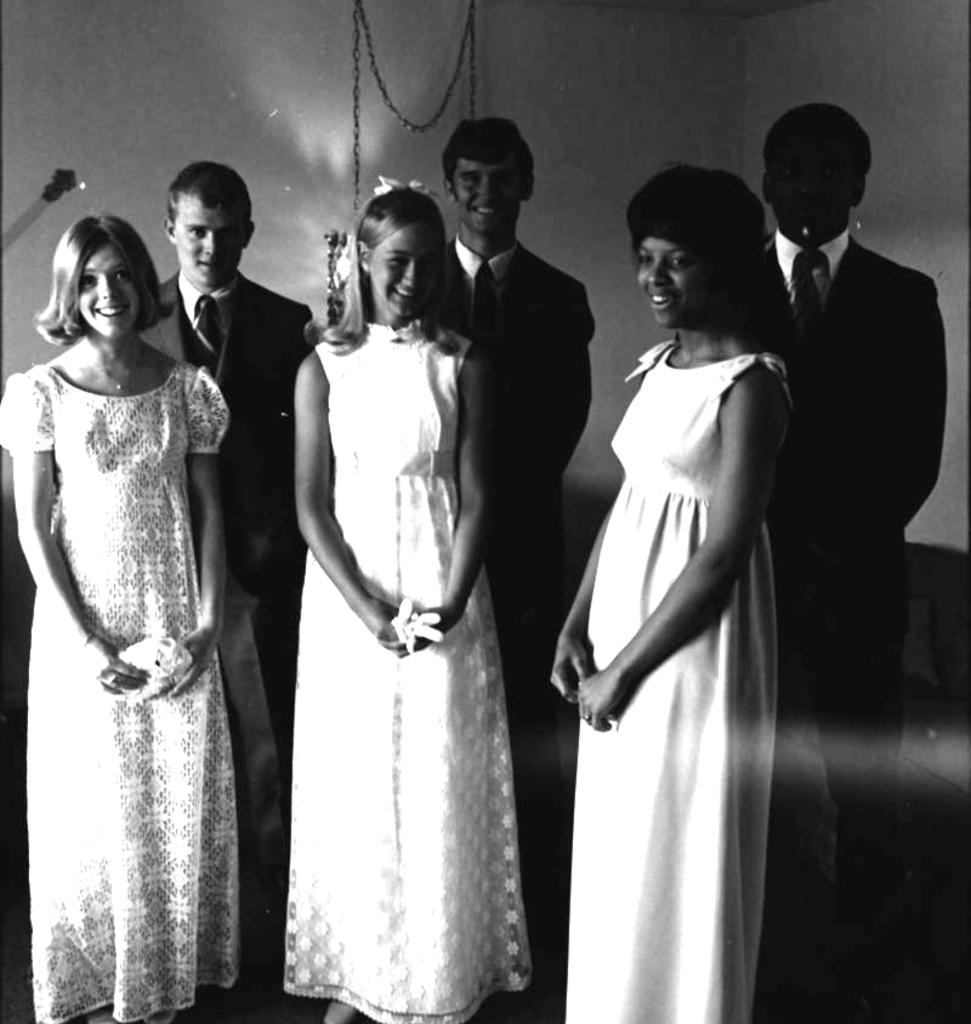What is the color scheme of the image? The image is black and white. Can you describe the subjects in the image? There are persons in the image. What can be seen in the background of the image? There is a wall in the background of the image. What type of library is depicted in the image? There is no library present in the image; it features black and white persons and a wall in the background. Can you provide an example of a protest happening in the image? There is no protest depicted in the image; it only shows persons and a wall in the background. 